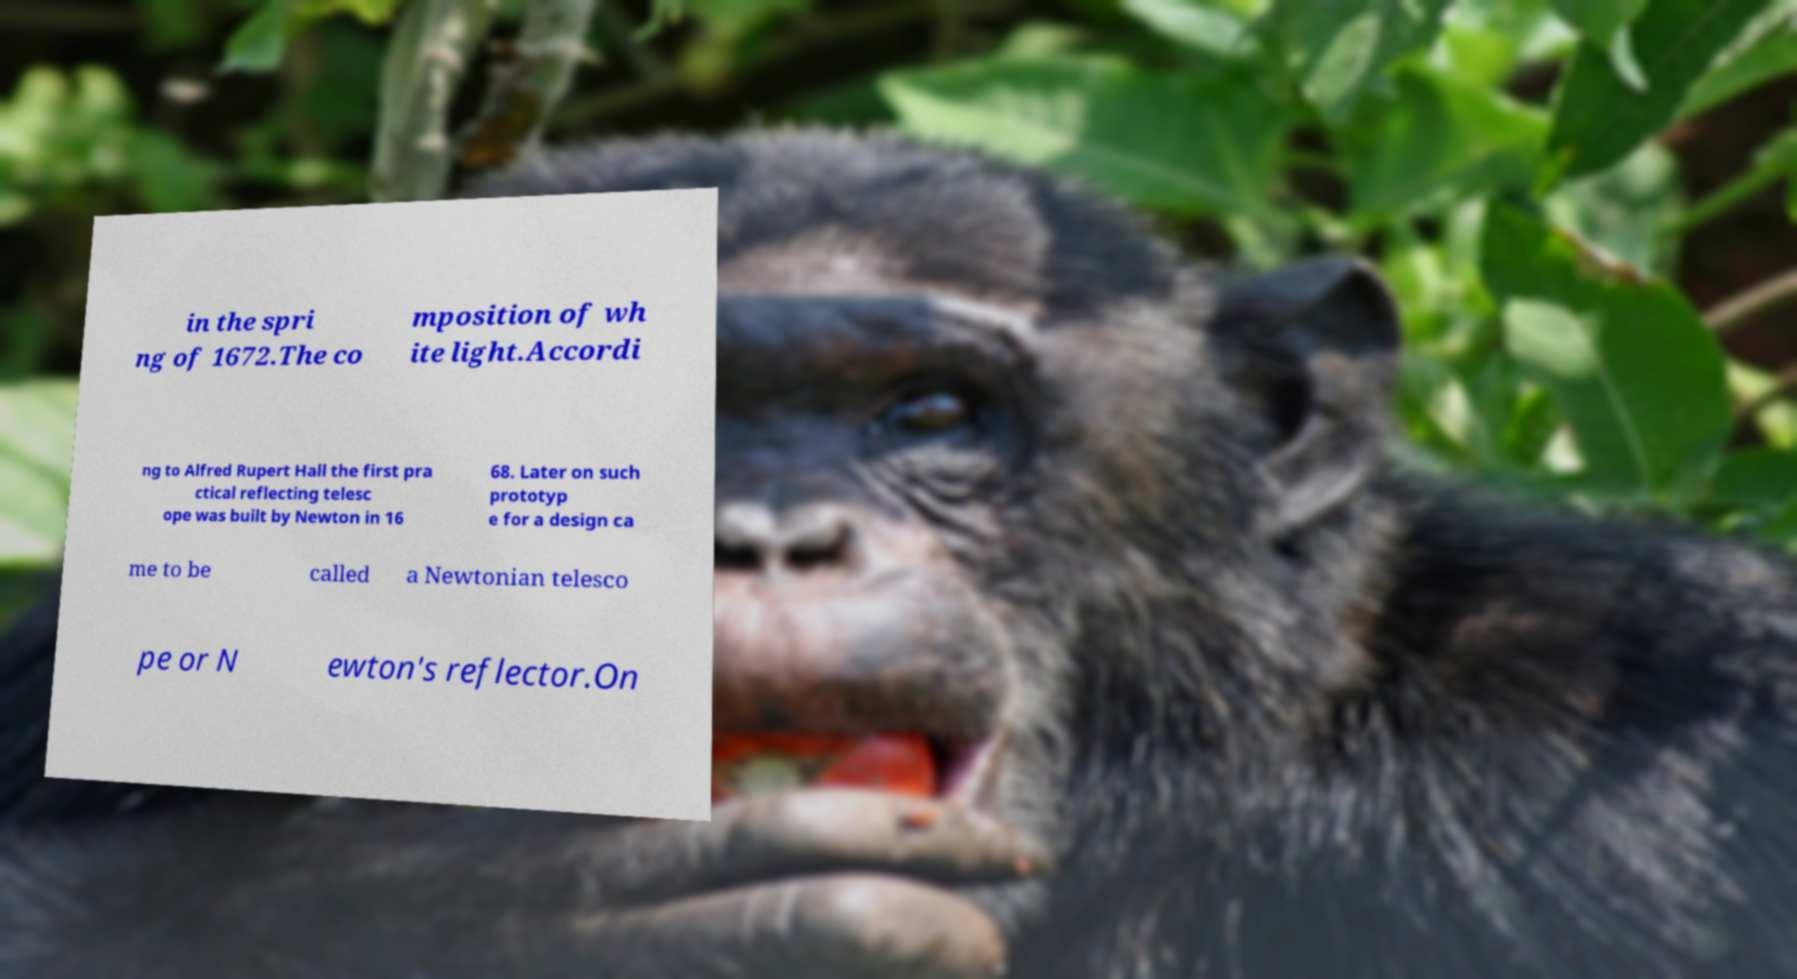What messages or text are displayed in this image? I need them in a readable, typed format. in the spri ng of 1672.The co mposition of wh ite light.Accordi ng to Alfred Rupert Hall the first pra ctical reflecting telesc ope was built by Newton in 16 68. Later on such prototyp e for a design ca me to be called a Newtonian telesco pe or N ewton's reflector.On 